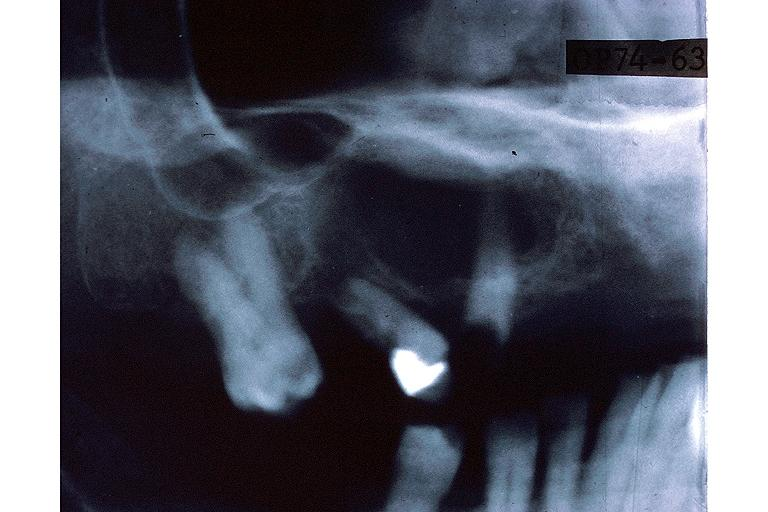what is present?
Answer the question using a single word or phrase. Oral 